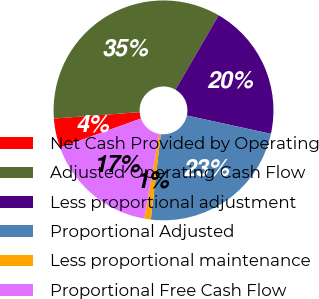Convert chart. <chart><loc_0><loc_0><loc_500><loc_500><pie_chart><fcel>Net Cash Provided by Operating<fcel>Adjusted Operating Cash Flow<fcel>Less proportional adjustment<fcel>Proportional Adjusted<fcel>Less proportional maintenance<fcel>Proportional Free Cash Flow<nl><fcel>4.32%<fcel>34.55%<fcel>20.06%<fcel>23.42%<fcel>0.96%<fcel>16.7%<nl></chart> 